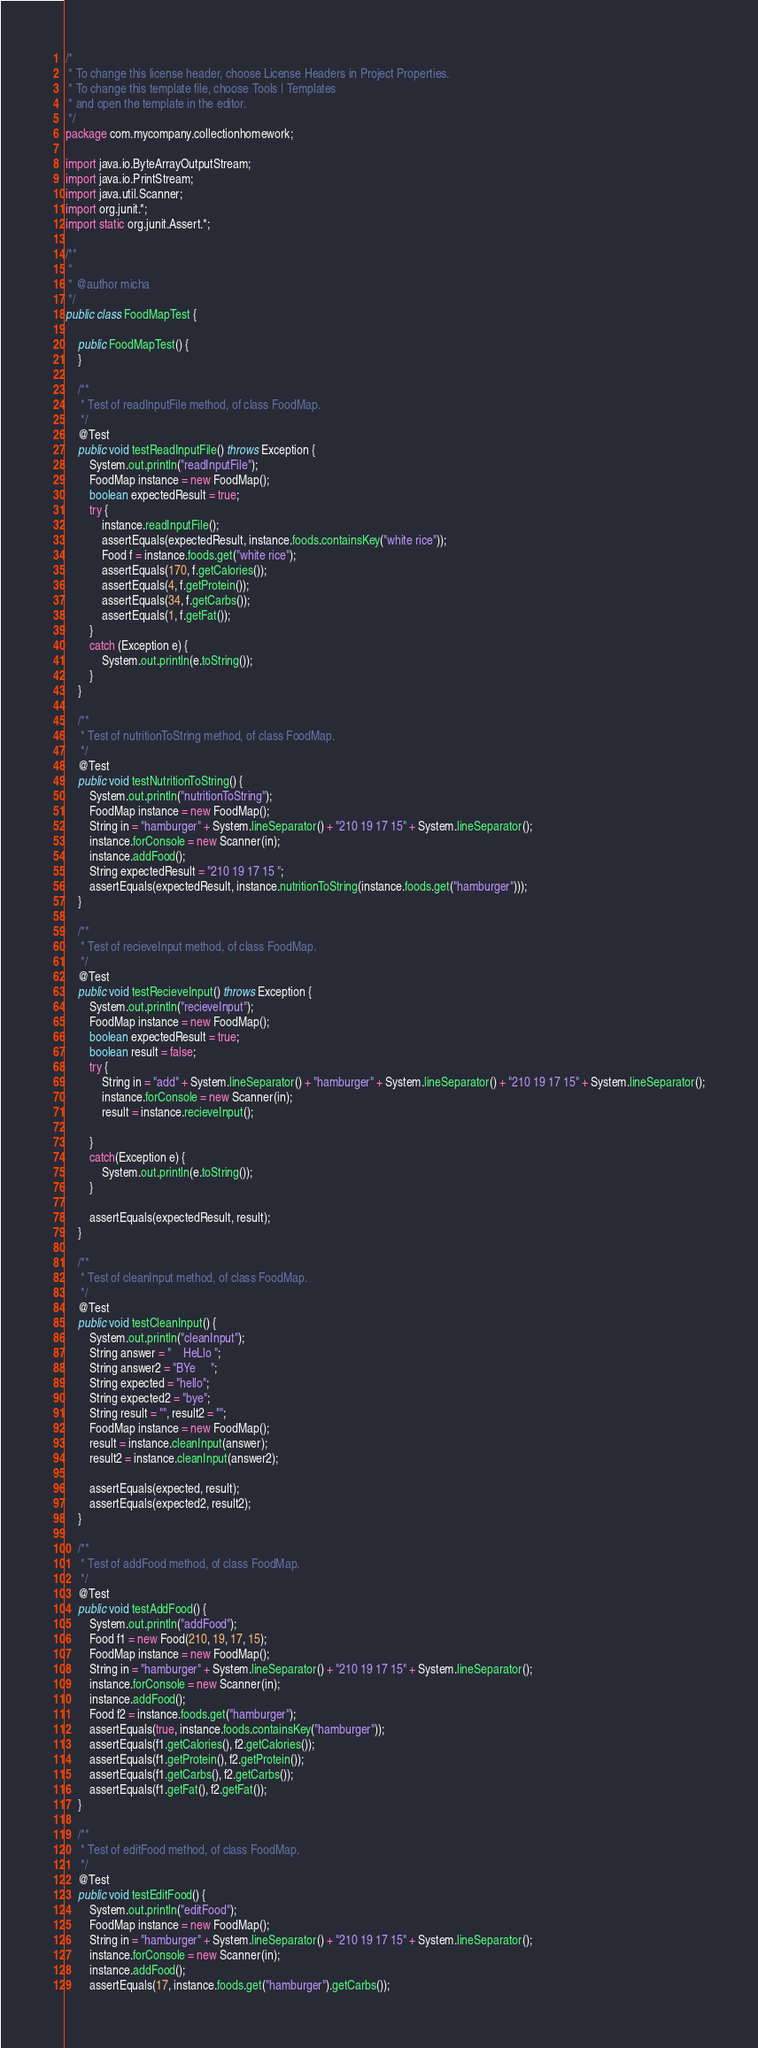<code> <loc_0><loc_0><loc_500><loc_500><_Java_>/*
 * To change this license header, choose License Headers in Project Properties.
 * To change this template file, choose Tools | Templates
 * and open the template in the editor.
 */
package com.mycompany.collectionhomework;

import java.io.ByteArrayOutputStream;
import java.io.PrintStream;
import java.util.Scanner;
import org.junit.*;
import static org.junit.Assert.*;

/**
 *
 * @author micha
 */
public class FoodMapTest {
    
    public FoodMapTest() {
    }
    
    /**
     * Test of readInputFile method, of class FoodMap.
     */
    @Test
    public void testReadInputFile() throws Exception {
        System.out.println("readInputFile");
        FoodMap instance = new FoodMap();
        boolean expectedResult = true;
        try {
            instance.readInputFile();
            assertEquals(expectedResult, instance.foods.containsKey("white rice"));
            Food f = instance.foods.get("white rice");
            assertEquals(170, f.getCalories());
            assertEquals(4, f.getProtein());
            assertEquals(34, f.getCarbs());
            assertEquals(1, f.getFat());
        }
        catch (Exception e) {
            System.out.println(e.toString());
        }
    }

    /**
     * Test of nutritionToString method, of class FoodMap.
     */
    @Test
    public void testNutritionToString() {
        System.out.println("nutritionToString");
        FoodMap instance = new FoodMap();
        String in = "hamburger" + System.lineSeparator() + "210 19 17 15" + System.lineSeparator();
        instance.forConsole = new Scanner(in);
        instance.addFood();
        String expectedResult = "210 19 17 15 ";
        assertEquals(expectedResult, instance.nutritionToString(instance.foods.get("hamburger")));
    }

    /**
     * Test of recieveInput method, of class FoodMap.
     */
    @Test
    public void testRecieveInput() throws Exception {
        System.out.println("recieveInput");
        FoodMap instance = new FoodMap();
        boolean expectedResult = true;
        boolean result = false;
        try {
            String in = "add" + System.lineSeparator() + "hamburger" + System.lineSeparator() + "210 19 17 15" + System.lineSeparator();
            instance.forConsole = new Scanner(in);
            result = instance.recieveInput();
            
        }
        catch(Exception e) {
            System.out.println(e.toString());
        }
        
        assertEquals(expectedResult, result);
    }

    /**
     * Test of cleanInput method, of class FoodMap.
     */
    @Test
    public void testCleanInput() {
        System.out.println("cleanInput");
        String answer = "    HeLlo ";
        String answer2 = "BYe     ";
        String expected = "hello";
        String expected2 = "bye";
        String result = "", result2 = "";
        FoodMap instance = new FoodMap();
        result = instance.cleanInput(answer);
        result2 = instance.cleanInput(answer2);
        
        assertEquals(expected, result);
        assertEquals(expected2, result2);
    }

    /**
     * Test of addFood method, of class FoodMap.
     */
    @Test
    public void testAddFood() {
        System.out.println("addFood");
        Food f1 = new Food(210, 19, 17, 15);
        FoodMap instance = new FoodMap();
        String in = "hamburger" + System.lineSeparator() + "210 19 17 15" + System.lineSeparator();
        instance.forConsole = new Scanner(in);
        instance.addFood();
        Food f2 = instance.foods.get("hamburger");
        assertEquals(true, instance.foods.containsKey("hamburger"));
        assertEquals(f1.getCalories(), f2.getCalories());
        assertEquals(f1.getProtein(), f2.getProtein());
        assertEquals(f1.getCarbs(), f2.getCarbs());
        assertEquals(f1.getFat(), f2.getFat());
    }

    /**
     * Test of editFood method, of class FoodMap.
     */
    @Test
    public void testEditFood() {
        System.out.println("editFood");
        FoodMap instance = new FoodMap();
        String in = "hamburger" + System.lineSeparator() + "210 19 17 15" + System.lineSeparator();
        instance.forConsole = new Scanner(in);
        instance.addFood();
        assertEquals(17, instance.foods.get("hamburger").getCarbs());</code> 